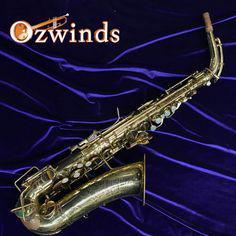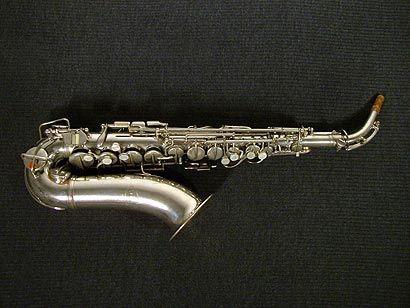The first image is the image on the left, the second image is the image on the right. Given the left and right images, does the statement "One image shows a saxophone with mouthpiece attached displayed on folds of blue velvet with its bell turned rightward." hold true? Answer yes or no. Yes. The first image is the image on the left, the second image is the image on the right. For the images displayed, is the sentence "The left and right image contains the same number saxophone and one if fully put together while the other is missing it's mouthpiece." factually correct? Answer yes or no. No. 